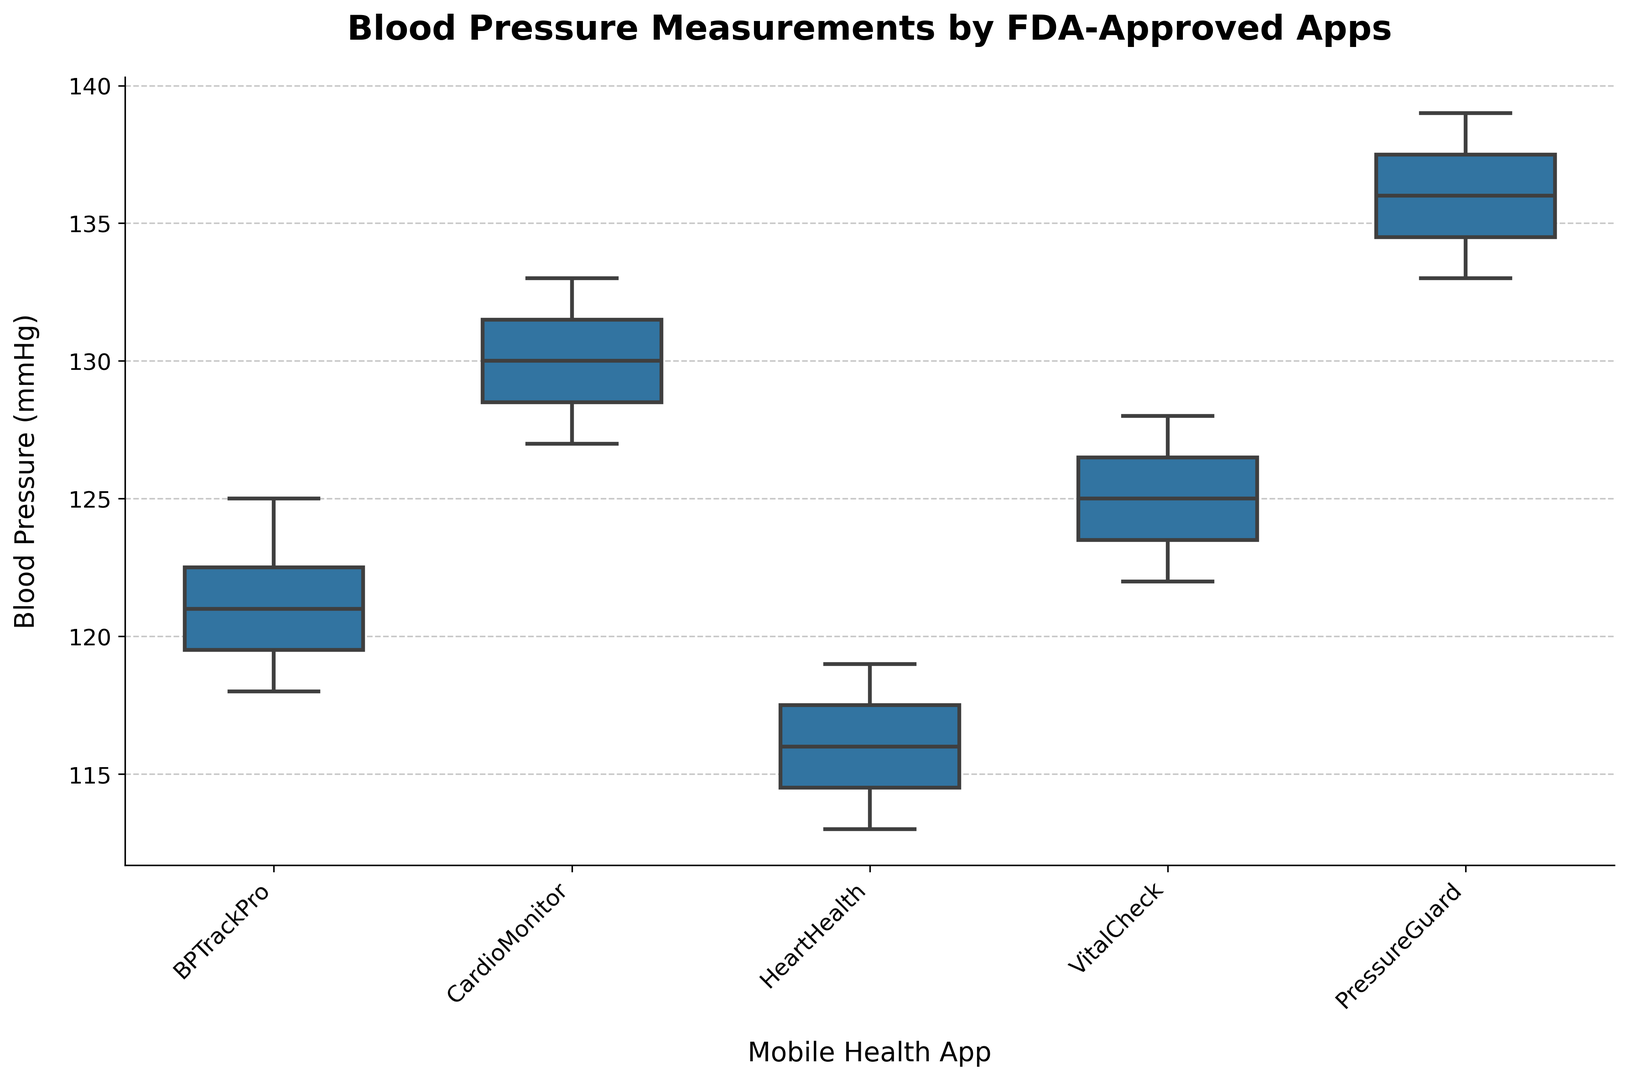What is the median blood pressure measurement for the BPTrackPro app? The box plot visually shows the median line inside the box for each app. For BPTrackPro, look for the horizontal line in the center of the box.
Answer: 121 mmHg Which app recorded the highest blood pressure measurement, and what is the value? The top whisker of each box plot represents the maximum value. The app with the highest position of the top whisker is PressureGuard, which has a top whisker at 139 mmHg.
Answer: PressureGuard, 139 mmHg Which app has the widest interquartile range (IQR)? The interquartile range (IQR) is represented by the height of the box. Look for the tallest box among the plotted apps.
Answer: CardioMonitor What is the range of blood pressure measurements recorded by HeartHealth? The range is the difference between the maximum and minimum values. For HeartHealth, look at the top and bottom whiskers. The top whisker is at 119 mmHg, and the bottom whisker is at 113 mmHg. The range is 119 - 113.
Answer: 6 mmHg Compare the medians of the CardioMonitor and VitalCheck apps. Which one has a higher median? The median is indicated by the horizontal line inside each box. Compare the positions of these lines for CardioMonitor and VitalCheck.
Answer: CardioMonitor Which app has the smallest difference between its median and its highest value? Calculate the difference between the median line and the top whisker for each app. The app with the smallest difference has its top whisker closest to its median line.
Answer: PressureGuard List the apps in descending order based on their lowest recorded blood pressure measurement. Check the bottom whisker for each app and order them from the highest to the lowest whisker point.
Answer: PressureGuard, CardioMonitor, VitalCheck, BPTrackPro, HeartHealth What is the third quartile (Q3) value for the VitalCheck app? The third quartile (Q3) is the top boundary of the box. For VitalCheck, look at the top edge of the box plot.
Answer: 127 mmHg 